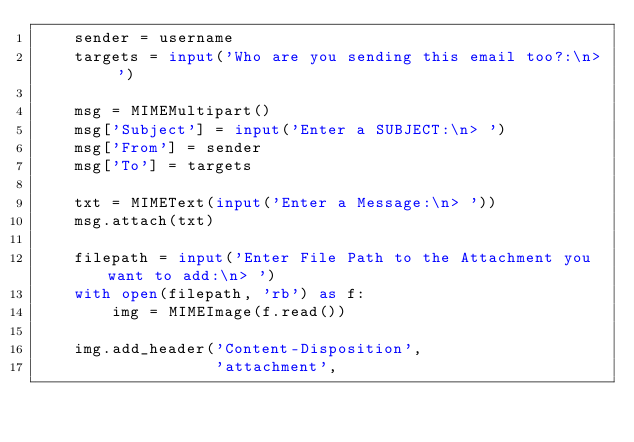Convert code to text. <code><loc_0><loc_0><loc_500><loc_500><_Python_>    sender = username
    targets = input('Who are you sending this email too?:\n> ')

    msg = MIMEMultipart()
    msg['Subject'] = input('Enter a SUBJECT:\n> ')
    msg['From'] = sender
    msg['To'] = targets

    txt = MIMEText(input('Enter a Message:\n> '))
    msg.attach(txt)

    filepath = input('Enter File Path to the Attachment you want to add:\n> ')
    with open(filepath, 'rb') as f:
        img = MIMEImage(f.read())

    img.add_header('Content-Disposition',
                   'attachment',</code> 